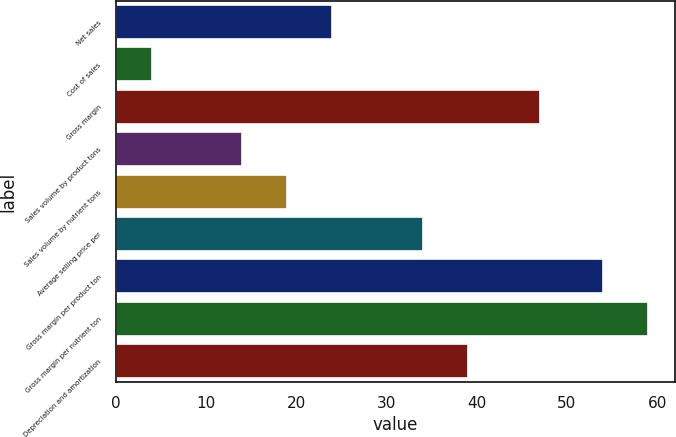Convert chart. <chart><loc_0><loc_0><loc_500><loc_500><bar_chart><fcel>Net sales<fcel>Cost of sales<fcel>Gross margin<fcel>Sales volume by product tons<fcel>Sales volume by nutrient tons<fcel>Average selling price per<fcel>Gross margin per product ton<fcel>Gross margin per nutrient ton<fcel>Depreciation and amortization<nl><fcel>24<fcel>4<fcel>47<fcel>14<fcel>19<fcel>34<fcel>54<fcel>59<fcel>39<nl></chart> 